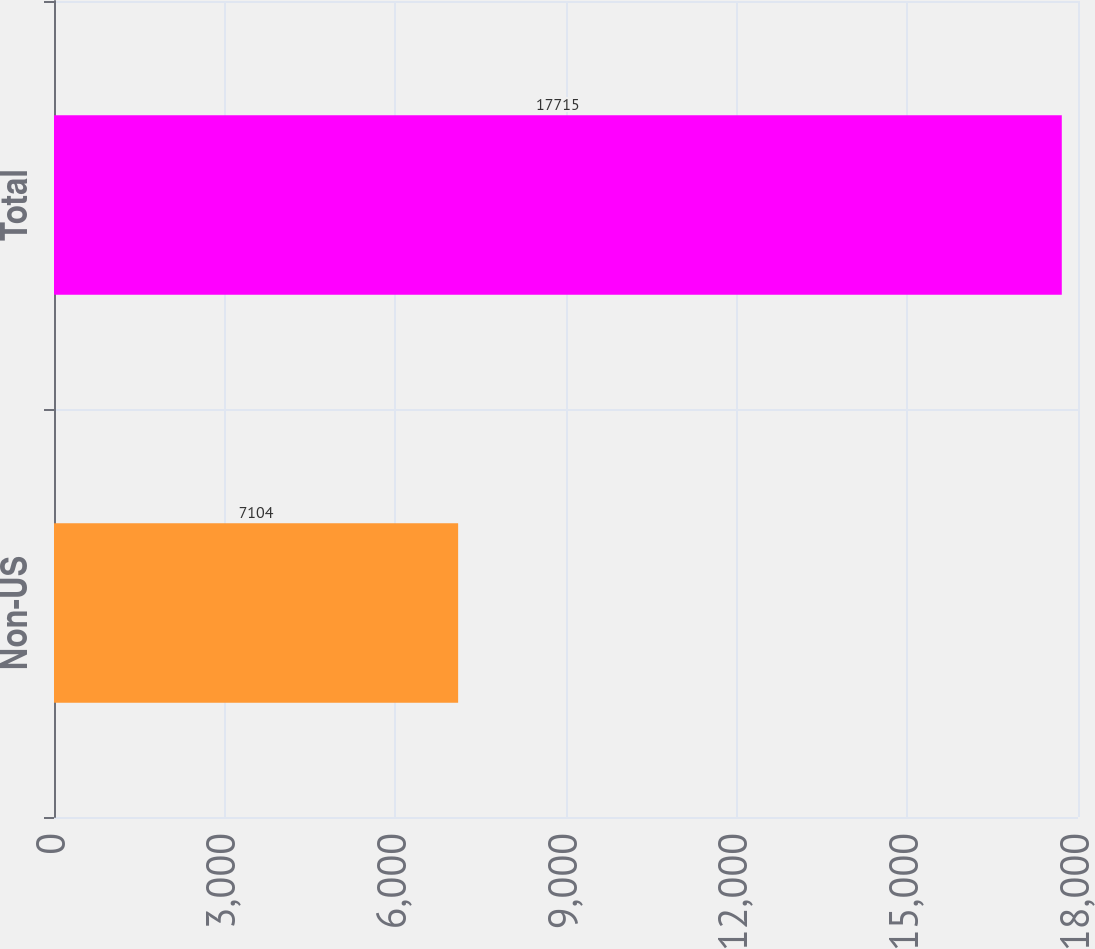<chart> <loc_0><loc_0><loc_500><loc_500><bar_chart><fcel>Non-US<fcel>Total<nl><fcel>7104<fcel>17715<nl></chart> 